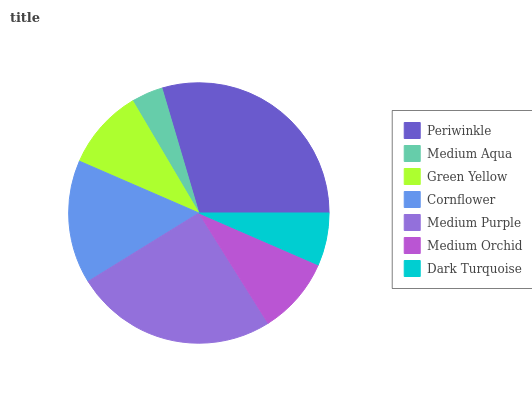Is Medium Aqua the minimum?
Answer yes or no. Yes. Is Periwinkle the maximum?
Answer yes or no. Yes. Is Green Yellow the minimum?
Answer yes or no. No. Is Green Yellow the maximum?
Answer yes or no. No. Is Green Yellow greater than Medium Aqua?
Answer yes or no. Yes. Is Medium Aqua less than Green Yellow?
Answer yes or no. Yes. Is Medium Aqua greater than Green Yellow?
Answer yes or no. No. Is Green Yellow less than Medium Aqua?
Answer yes or no. No. Is Green Yellow the high median?
Answer yes or no. Yes. Is Green Yellow the low median?
Answer yes or no. Yes. Is Medium Purple the high median?
Answer yes or no. No. Is Periwinkle the low median?
Answer yes or no. No. 